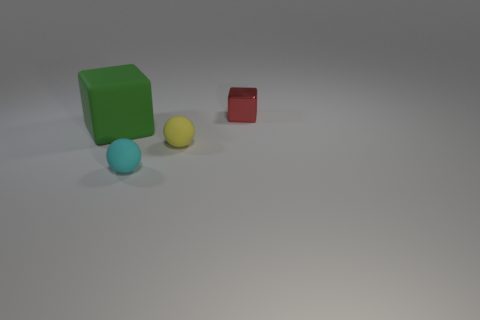Add 3 small yellow things. How many objects exist? 7 Add 2 yellow metal objects. How many yellow metal objects exist? 2 Subtract 1 green cubes. How many objects are left? 3 Subtract all tiny cyan rubber objects. Subtract all red things. How many objects are left? 2 Add 4 tiny red metal objects. How many tiny red metal objects are left? 5 